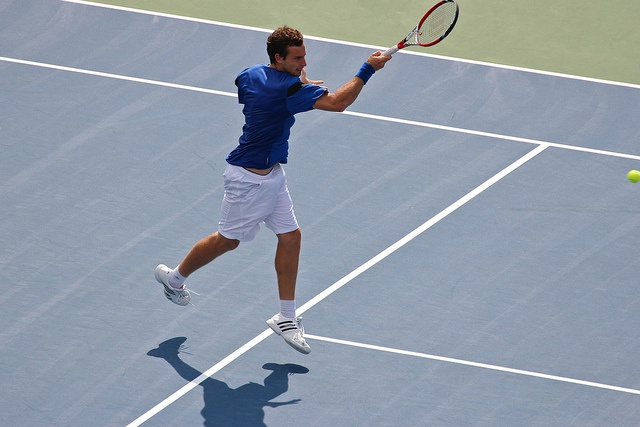Describe the objects in this image and their specific colors. I can see people in darkgray, navy, maroon, and black tones, tennis racket in darkgray, gray, black, and maroon tones, and sports ball in darkgray, olive, and khaki tones in this image. 